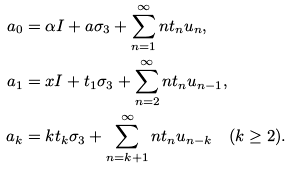<formula> <loc_0><loc_0><loc_500><loc_500>a _ { 0 } & = \alpha I + a \sigma _ { 3 } + \sum _ { n = 1 } ^ { \infty } n t _ { n } u _ { n } , \\ a _ { 1 } & = x I + t _ { 1 } \sigma _ { 3 } + \sum _ { n = 2 } ^ { \infty } n t _ { n } u _ { n - 1 } , \\ a _ { k } & = k t _ { k } \sigma _ { 3 } + \sum _ { n = k + 1 } ^ { \infty } n t _ { n } u _ { n - k } \quad ( k \geq 2 ) .</formula> 